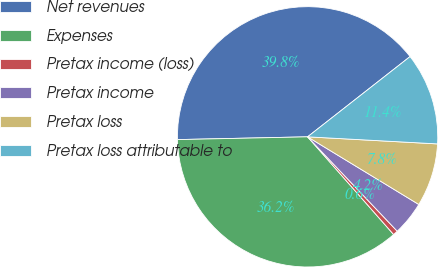Convert chart. <chart><loc_0><loc_0><loc_500><loc_500><pie_chart><fcel>Net revenues<fcel>Expenses<fcel>Pretax income (loss)<fcel>Pretax income<fcel>Pretax loss<fcel>Pretax loss attributable to<nl><fcel>39.76%<fcel>36.15%<fcel>0.6%<fcel>4.21%<fcel>7.83%<fcel>11.44%<nl></chart> 